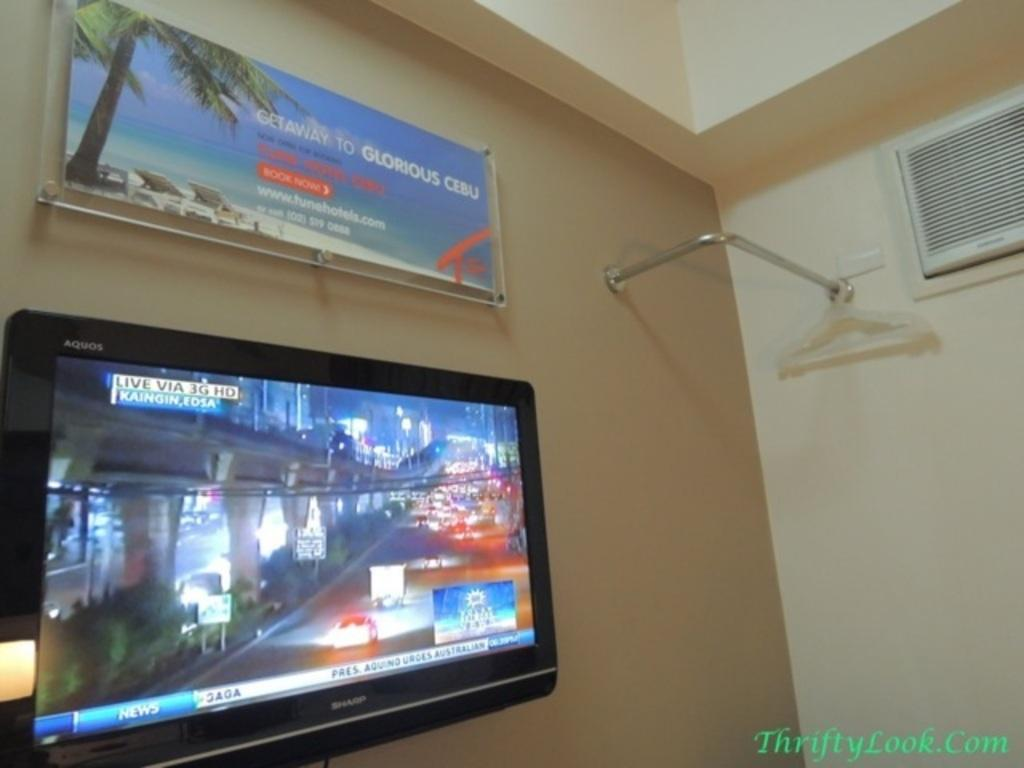<image>
Summarize the visual content of the image. A travel poster for Cebu hangs over a wall mounted television. 